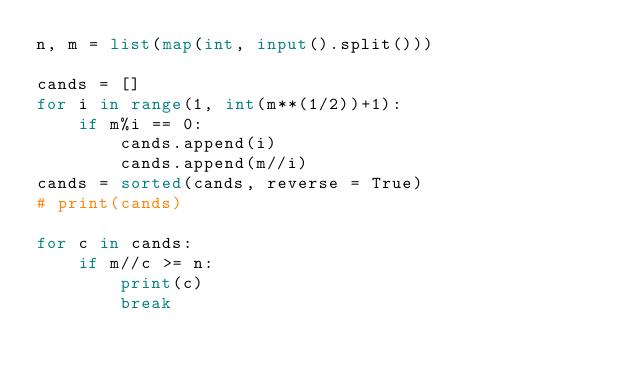<code> <loc_0><loc_0><loc_500><loc_500><_Python_>n, m = list(map(int, input().split()))

cands = []
for i in range(1, int(m**(1/2))+1):
    if m%i == 0:
        cands.append(i)
        cands.append(m//i)
cands = sorted(cands, reverse = True)
# print(cands)

for c in cands:
    if m//c >= n:
        print(c)
        break
</code> 